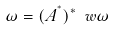<formula> <loc_0><loc_0><loc_500><loc_500>\omega = ( A ^ { ^ { * } } ) ^ { * } \ w \omega</formula> 